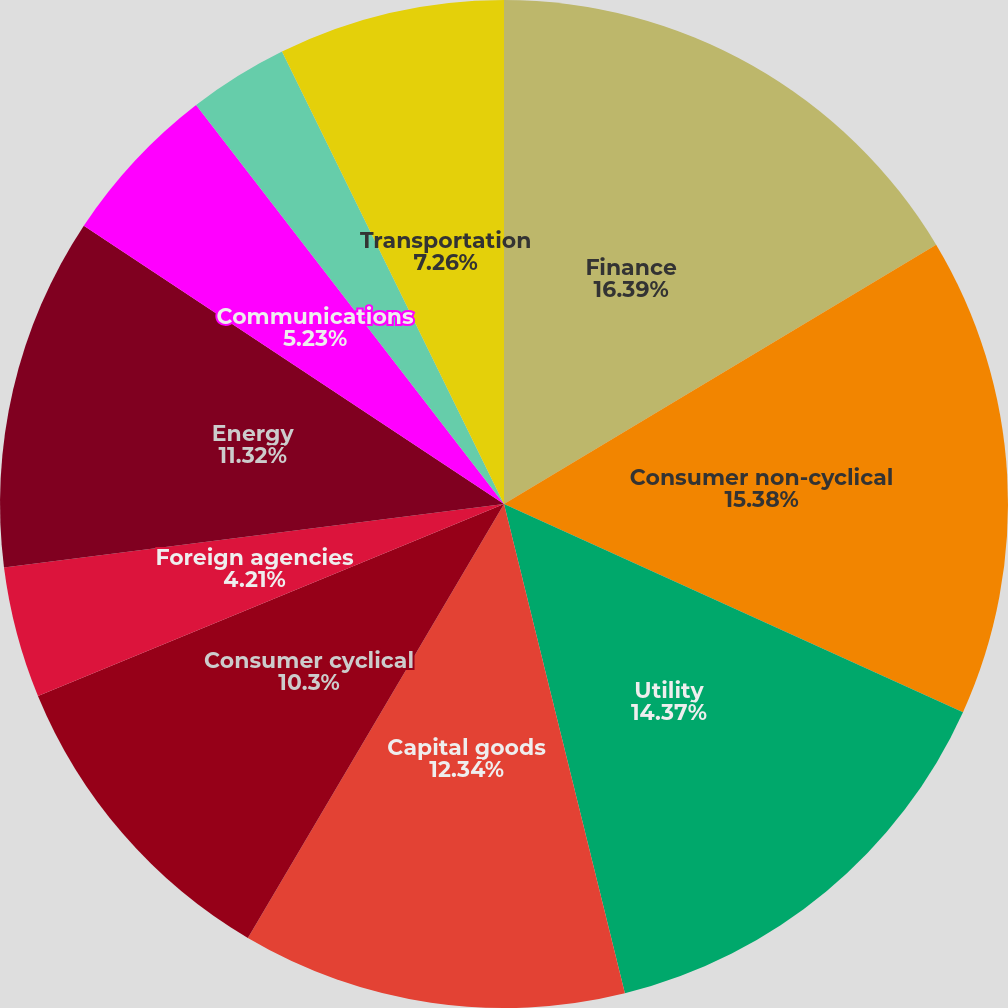Convert chart. <chart><loc_0><loc_0><loc_500><loc_500><pie_chart><fcel>Finance<fcel>Consumer non-cyclical<fcel>Utility<fcel>Capital goods<fcel>Consumer cyclical<fcel>Foreign agencies<fcel>Energy<fcel>Communications<fcel>Basic industry<fcel>Transportation<nl><fcel>16.4%<fcel>15.38%<fcel>14.37%<fcel>12.34%<fcel>10.3%<fcel>4.21%<fcel>11.32%<fcel>5.23%<fcel>3.2%<fcel>7.26%<nl></chart> 